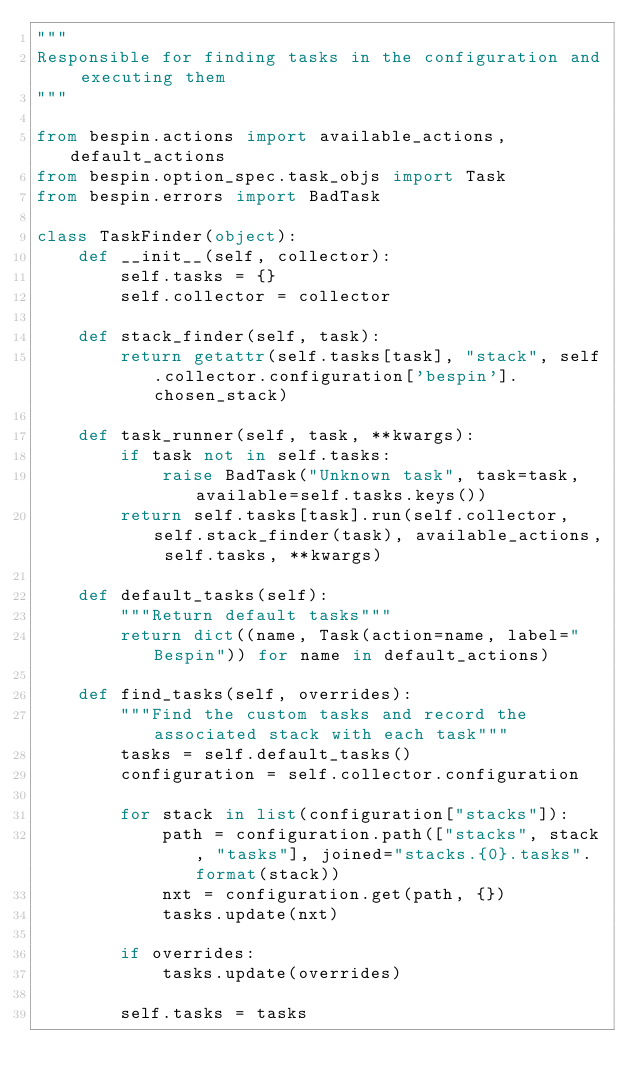<code> <loc_0><loc_0><loc_500><loc_500><_Python_>"""
Responsible for finding tasks in the configuration and executing them
"""

from bespin.actions import available_actions, default_actions
from bespin.option_spec.task_objs import Task
from bespin.errors import BadTask

class TaskFinder(object):
    def __init__(self, collector):
        self.tasks = {}
        self.collector = collector

    def stack_finder(self, task):
        return getattr(self.tasks[task], "stack", self.collector.configuration['bespin'].chosen_stack)

    def task_runner(self, task, **kwargs):
        if task not in self.tasks:
            raise BadTask("Unknown task", task=task, available=self.tasks.keys())
        return self.tasks[task].run(self.collector, self.stack_finder(task), available_actions, self.tasks, **kwargs)

    def default_tasks(self):
        """Return default tasks"""
        return dict((name, Task(action=name, label="Bespin")) for name in default_actions)

    def find_tasks(self, overrides):
        """Find the custom tasks and record the associated stack with each task"""
        tasks = self.default_tasks()
        configuration = self.collector.configuration

        for stack in list(configuration["stacks"]):
            path = configuration.path(["stacks", stack, "tasks"], joined="stacks.{0}.tasks".format(stack))
            nxt = configuration.get(path, {})
            tasks.update(nxt)

        if overrides:
            tasks.update(overrides)

        self.tasks = tasks

</code> 